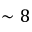<formula> <loc_0><loc_0><loc_500><loc_500>\sim 8</formula> 